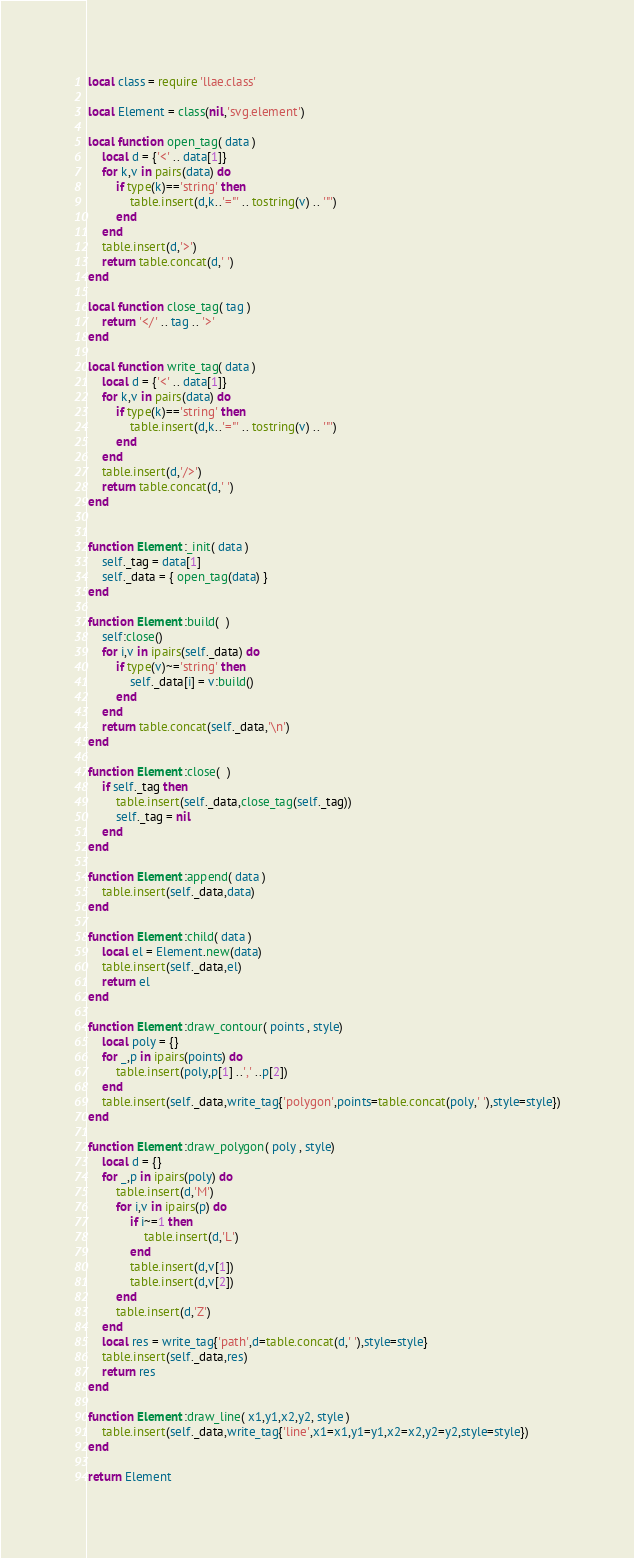<code> <loc_0><loc_0><loc_500><loc_500><_Lua_>local class = require 'llae.class'

local Element = class(nil,'svg.element')

local function open_tag( data )
	local d = {'<' .. data[1]}
	for k,v in pairs(data) do
		if type(k)=='string' then
			table.insert(d,k..'="' .. tostring(v) .. '"')
		end
	end
	table.insert(d,'>')
	return table.concat(d,' ')
end

local function close_tag( tag )
	return '</' .. tag .. '>'
end

local function write_tag( data )
	local d = {'<' .. data[1]}
	for k,v in pairs(data) do
		if type(k)=='string' then
			table.insert(d,k..'="' .. tostring(v) .. '"')
		end
	end
	table.insert(d,'/>')
	return table.concat(d,' ')
end


function Element:_init( data )
	self._tag = data[1]
	self._data = { open_tag(data) }
end

function Element:build(  )
	self:close()
	for i,v in ipairs(self._data) do
		if type(v)~='string' then
			self._data[i] = v:build()
		end
	end
	return table.concat(self._data,'\n')
end

function Element:close(  )
	if self._tag then
		table.insert(self._data,close_tag(self._tag))
		self._tag = nil
	end
end

function Element:append( data )
	table.insert(self._data,data)
end

function Element:child( data )
	local el = Element.new(data)
	table.insert(self._data,el)
	return el
end

function Element:draw_contour( points , style)
	local poly = {}
	for _,p in ipairs(points) do
		table.insert(poly,p[1] ..',' ..p[2])
	end
	table.insert(self._data,write_tag{'polygon',points=table.concat(poly,' '),style=style})
end

function Element:draw_polygon( poly , style)
	local d = {}
	for _,p in ipairs(poly) do
		table.insert(d,'M')
		for i,v in ipairs(p) do
			if i~=1 then
				table.insert(d,'L')
			end
			table.insert(d,v[1])
			table.insert(d,v[2])
		end
		table.insert(d,'Z')
	end
	local res = write_tag{'path',d=table.concat(d,' '),style=style}
	table.insert(self._data,res)
	return res
end

function Element:draw_line( x1,y1,x2,y2, style )
	table.insert(self._data,write_tag{'line',x1=x1,y1=y1,x2=x2,y2=y2,style=style})
end

return Element</code> 